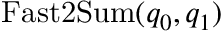<formula> <loc_0><loc_0><loc_500><loc_500>F a s t 2 S u m ( q _ { 0 } , q _ { 1 } )</formula> 